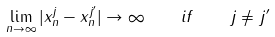Convert formula to latex. <formula><loc_0><loc_0><loc_500><loc_500>\lim _ { n \to \infty } | x _ { n } ^ { j } - x _ { n } ^ { j ^ { \prime } } | \to \infty \quad i f \quad j \neq j ^ { \prime }</formula> 